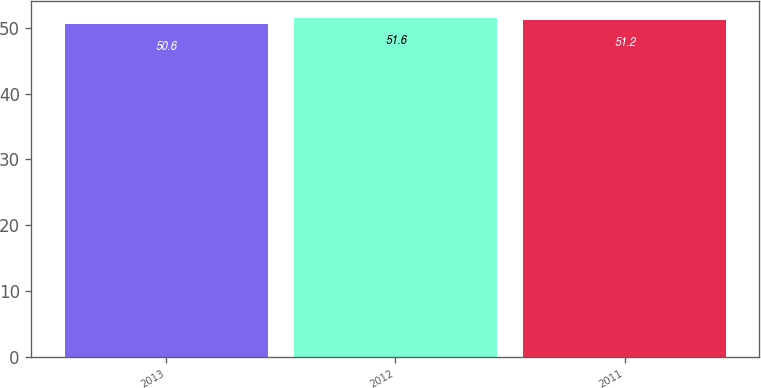Convert chart. <chart><loc_0><loc_0><loc_500><loc_500><bar_chart><fcel>2013<fcel>2012<fcel>2011<nl><fcel>50.6<fcel>51.6<fcel>51.2<nl></chart> 